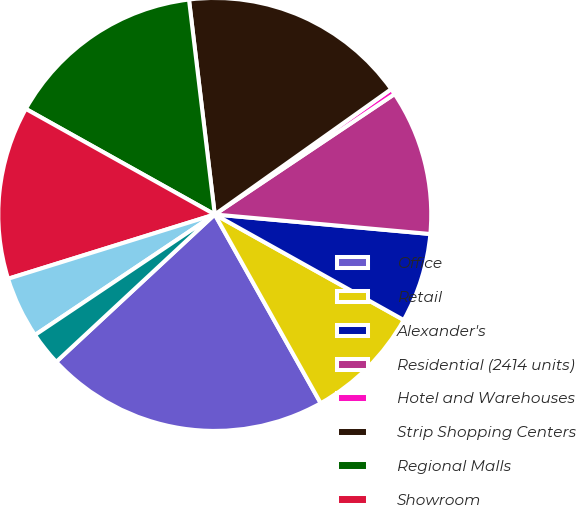Convert chart to OTSL. <chart><loc_0><loc_0><loc_500><loc_500><pie_chart><fcel>Office<fcel>Retail<fcel>Alexander's<fcel>Residential (2414 units)<fcel>Hotel and Warehouses<fcel>Strip Shopping Centers<fcel>Regional Malls<fcel>Showroom<fcel>555 California Street<fcel>Primarily Warehouses<nl><fcel>21.22%<fcel>8.75%<fcel>6.67%<fcel>10.83%<fcel>0.44%<fcel>17.07%<fcel>14.99%<fcel>12.91%<fcel>4.6%<fcel>2.52%<nl></chart> 